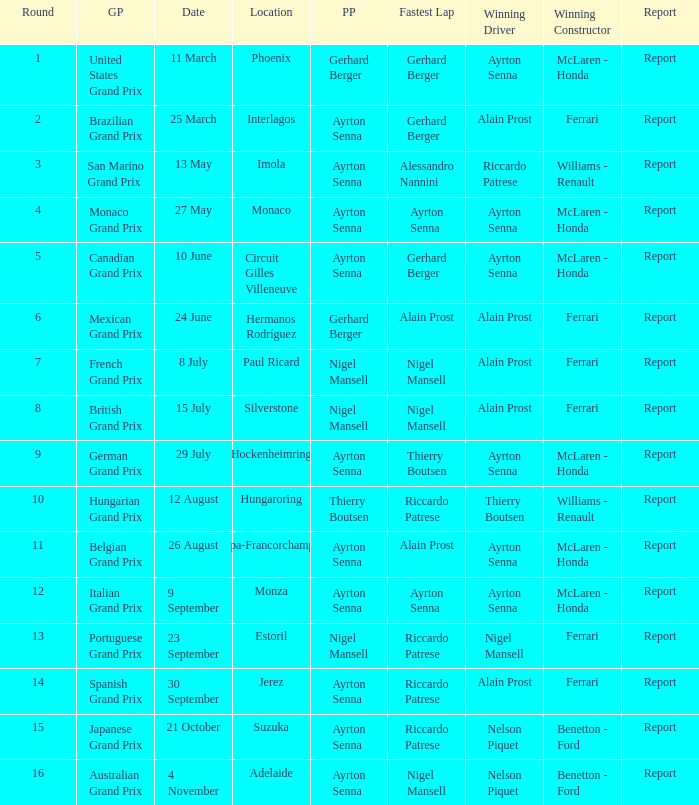What is the date that Ayrton Senna was the drive in Monza? 9 September. 